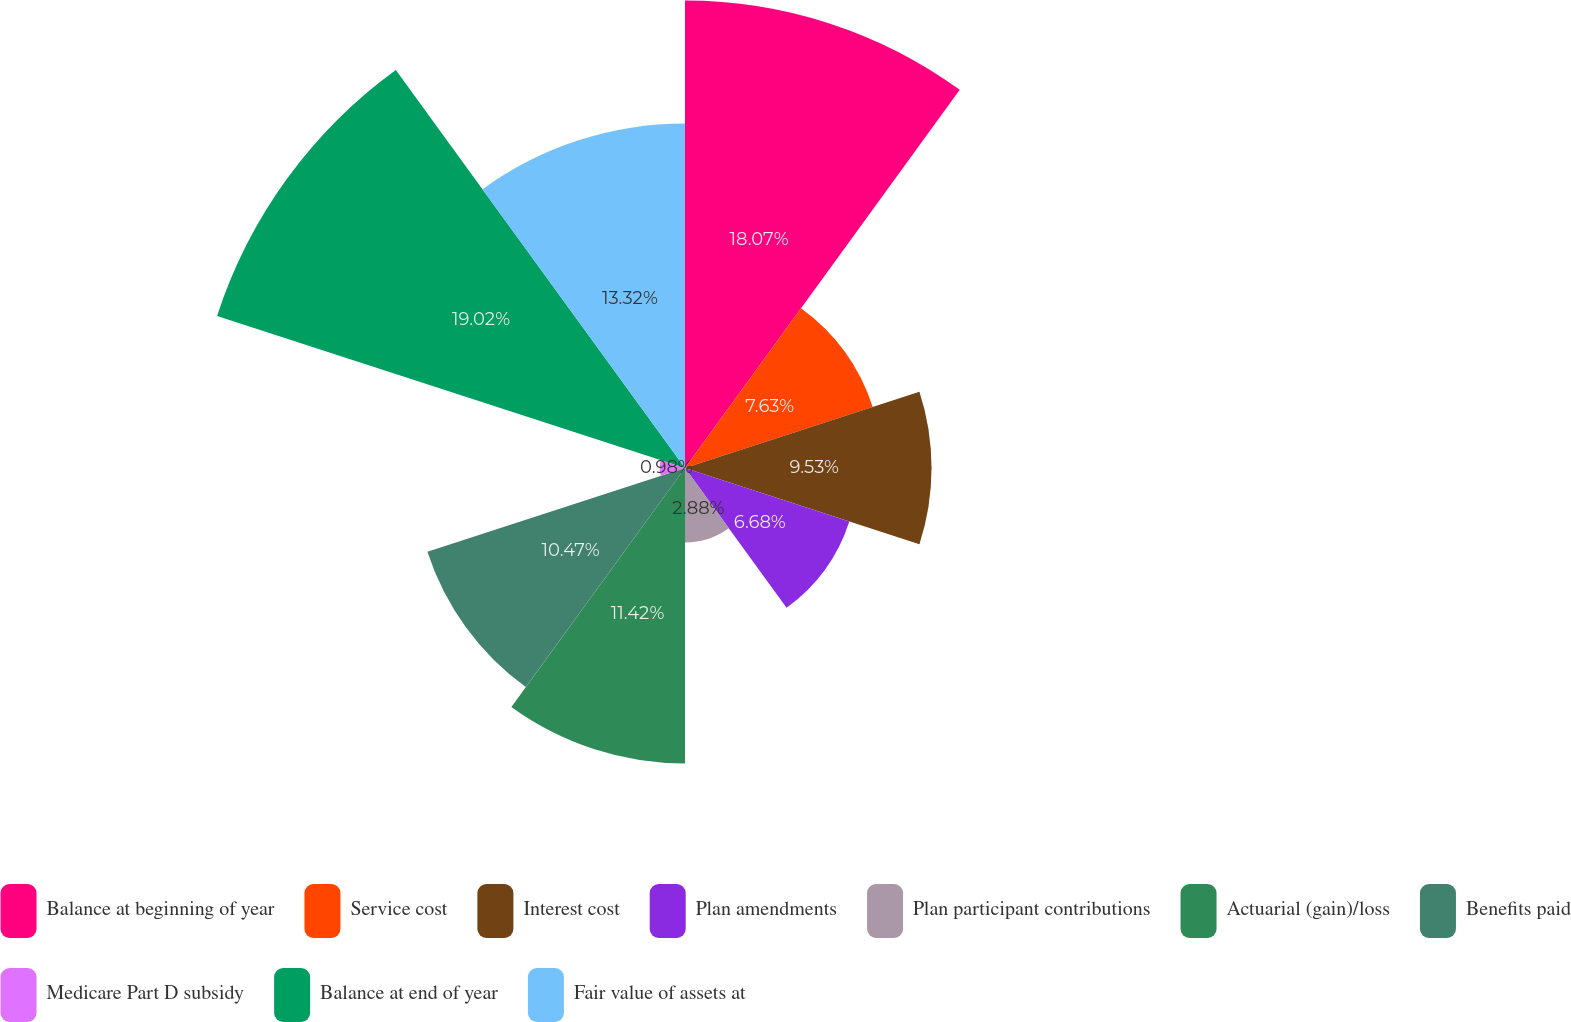Convert chart. <chart><loc_0><loc_0><loc_500><loc_500><pie_chart><fcel>Balance at beginning of year<fcel>Service cost<fcel>Interest cost<fcel>Plan amendments<fcel>Plan participant contributions<fcel>Actuarial (gain)/loss<fcel>Benefits paid<fcel>Medicare Part D subsidy<fcel>Balance at end of year<fcel>Fair value of assets at<nl><fcel>18.07%<fcel>7.63%<fcel>9.53%<fcel>6.68%<fcel>2.88%<fcel>11.42%<fcel>10.47%<fcel>0.98%<fcel>19.02%<fcel>13.32%<nl></chart> 